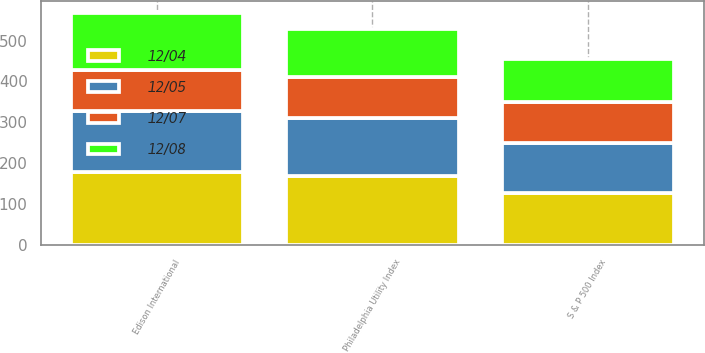Convert chart. <chart><loc_0><loc_0><loc_500><loc_500><stacked_bar_chart><ecel><fcel>Edison International<fcel>S & P 500 Index<fcel>Philadelphia Utility Index<nl><fcel>12/07<fcel>100<fcel>100<fcel>100<nl><fcel>12/08<fcel>140<fcel>105<fcel>118<nl><fcel>12/05<fcel>149<fcel>121<fcel>142<nl><fcel>12/04<fcel>179<fcel>128<fcel>169<nl></chart> 